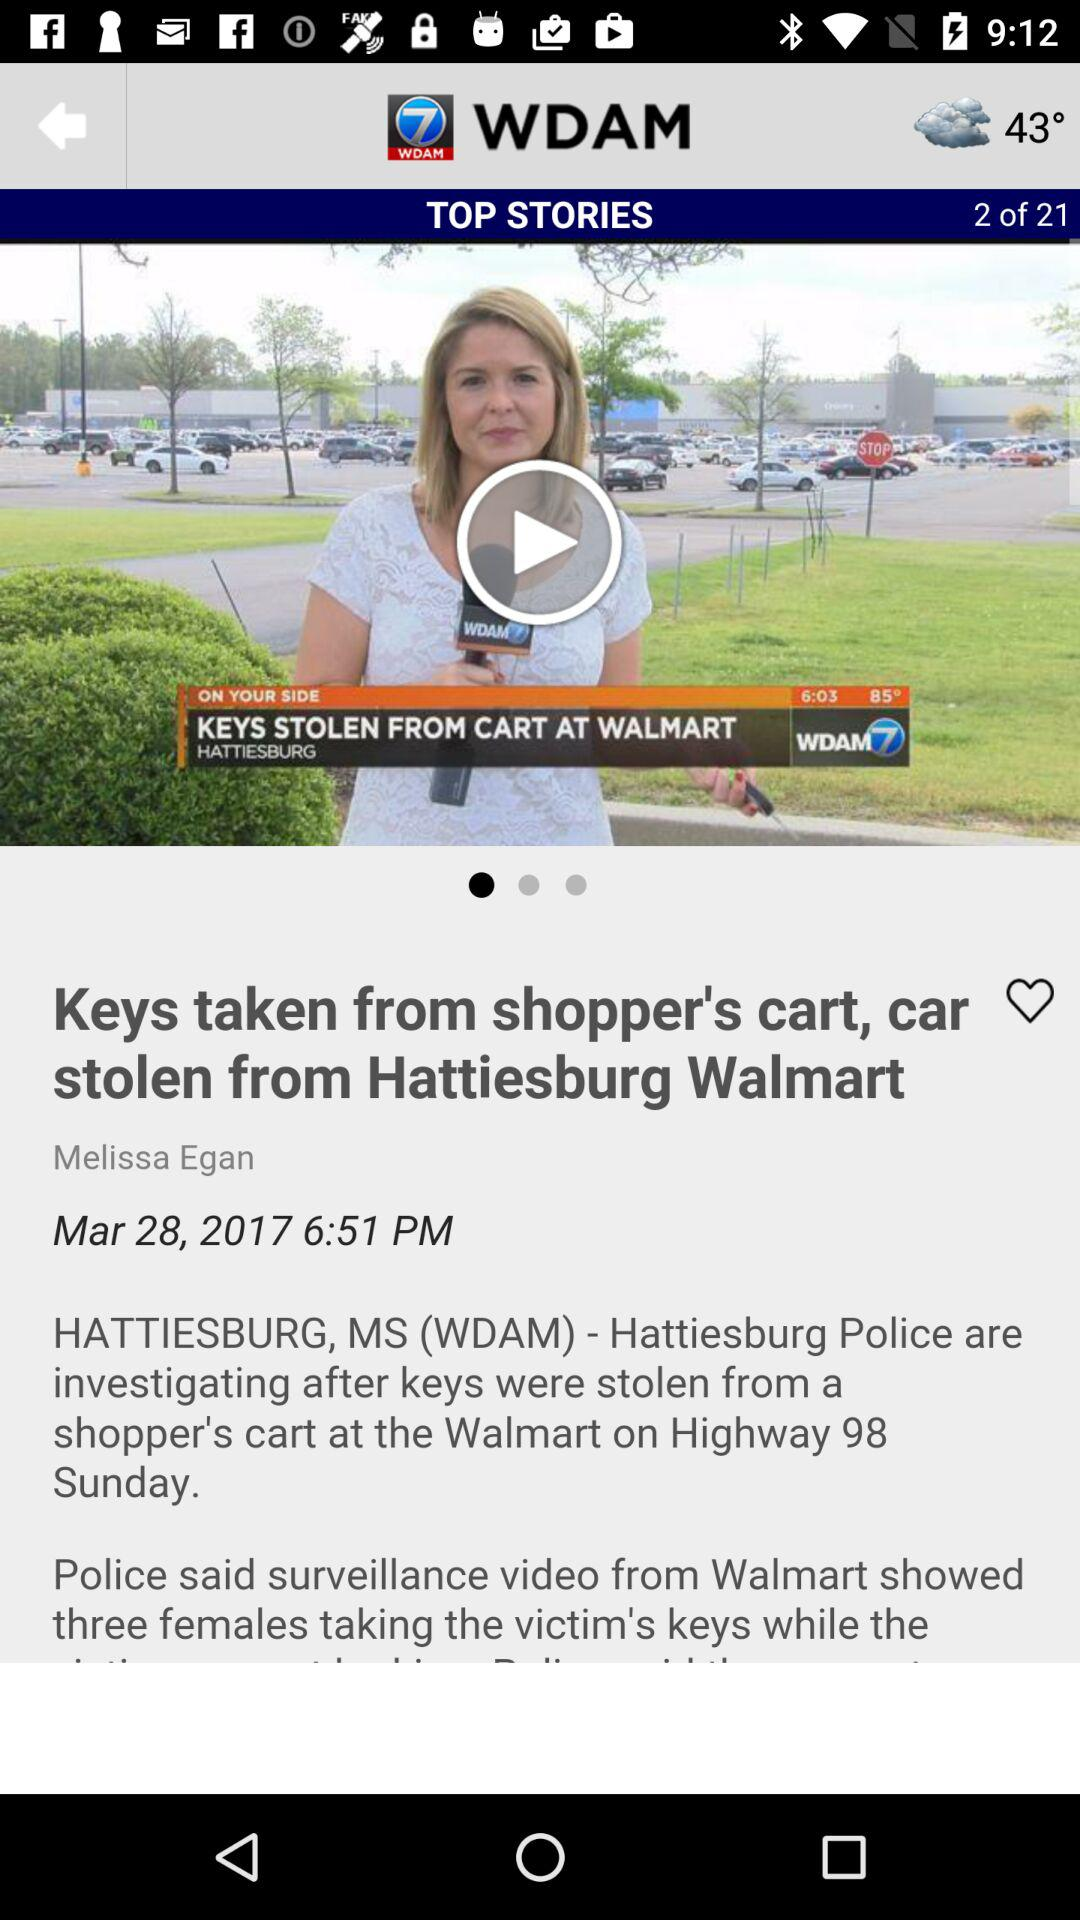How many top stories in total are there? There are 21 top stories. 